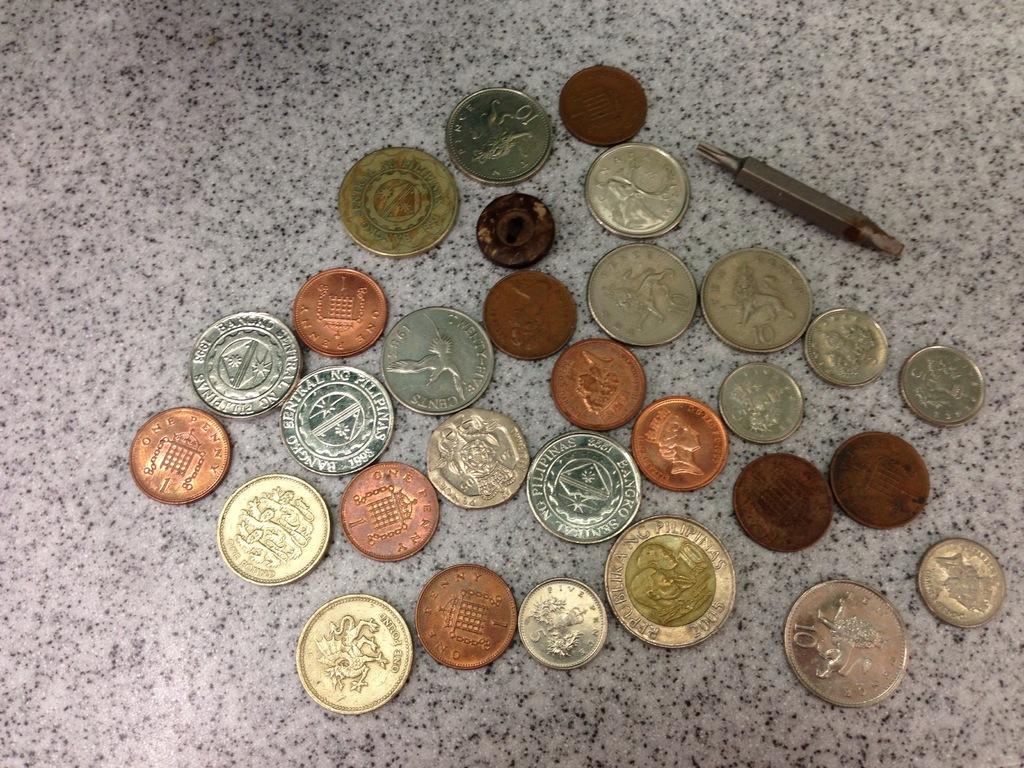What number is on the cooper coin on the left?
Offer a very short reply. 1. 